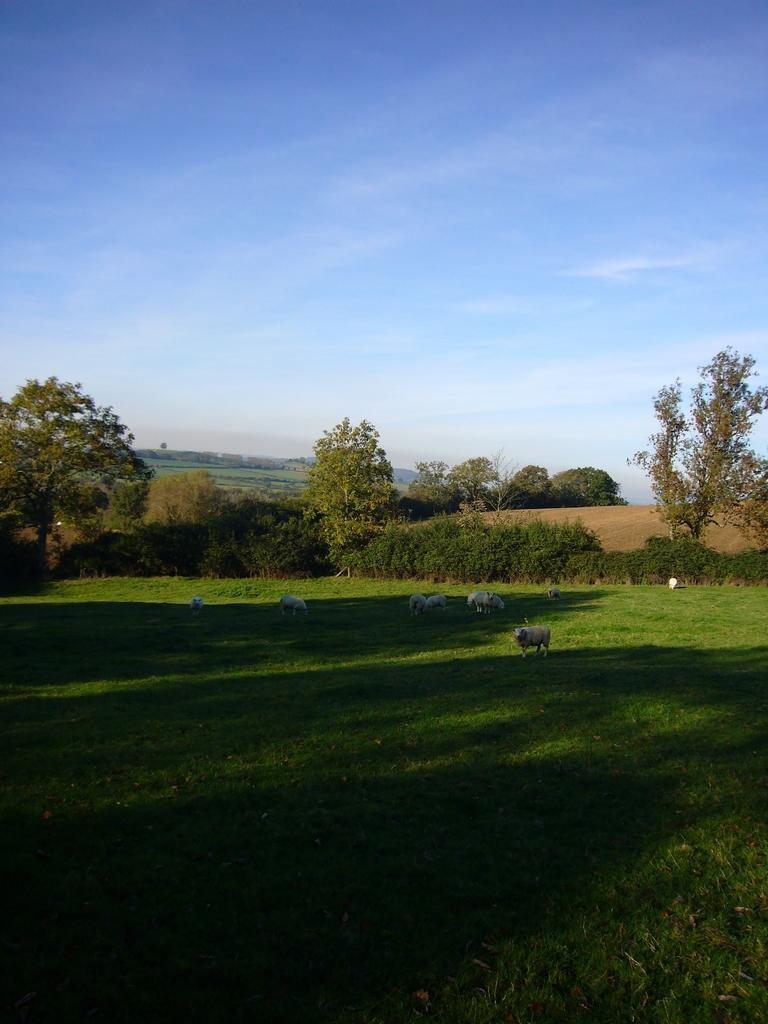How would you summarize this image in a sentence or two? This is an outside view. At the bottom, I can see the grass and there are few animals on the ground. In the background there are many trees. At the top of the image I can see the sky in blue color. 